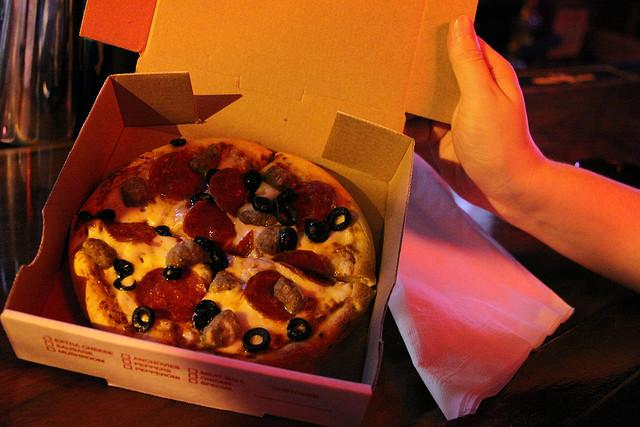What type person would enjoy this pizza? Please explain your reasoning. omnivore. The pizza has meat and veggies. 